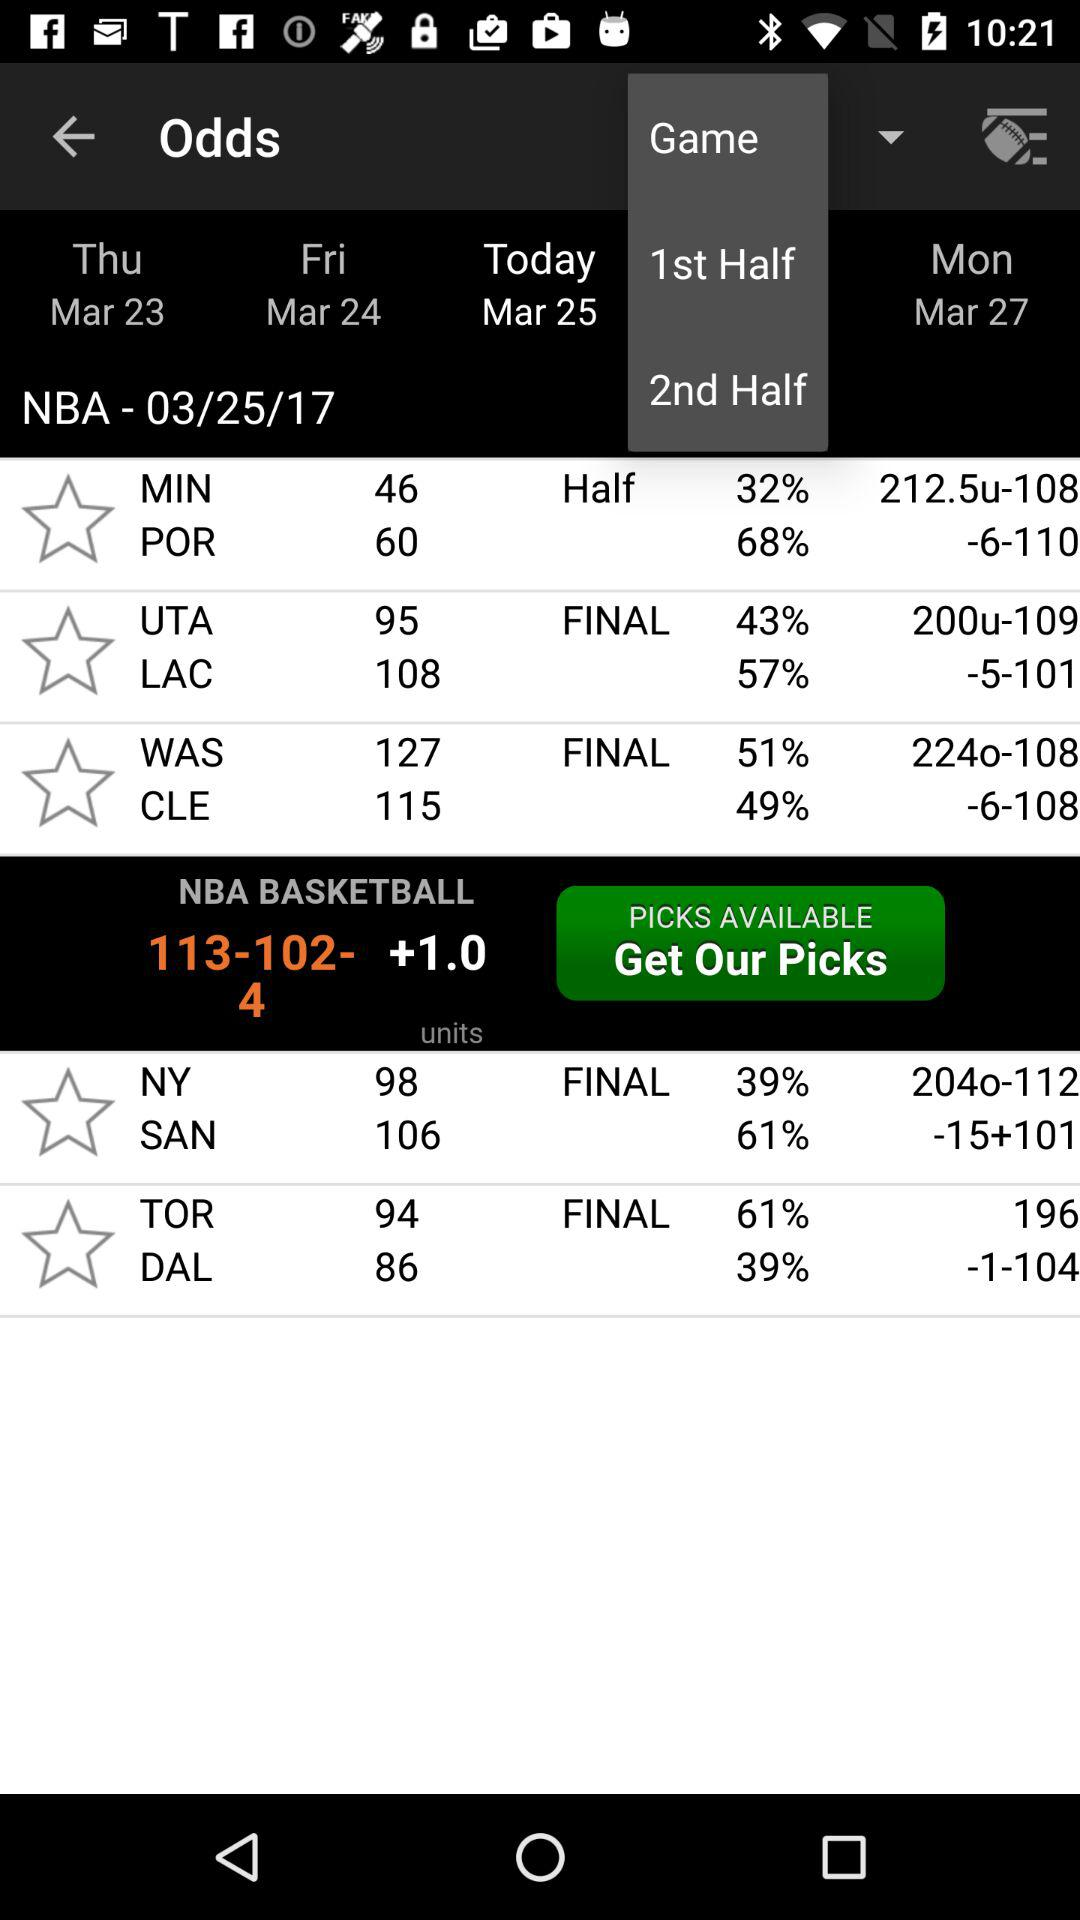Which day has been selected? The day that has been selected is "Today". 